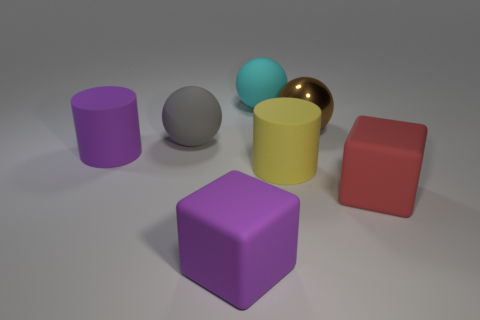Subtract all blue cylinders. Subtract all cyan blocks. How many cylinders are left? 2 Add 2 cyan rubber balls. How many objects exist? 9 Subtract all blocks. How many objects are left? 5 Subtract 0 blue cubes. How many objects are left? 7 Subtract all large red blocks. Subtract all large yellow cylinders. How many objects are left? 5 Add 2 large brown spheres. How many large brown spheres are left? 3 Add 3 big blue metal things. How many big blue metal things exist? 3 